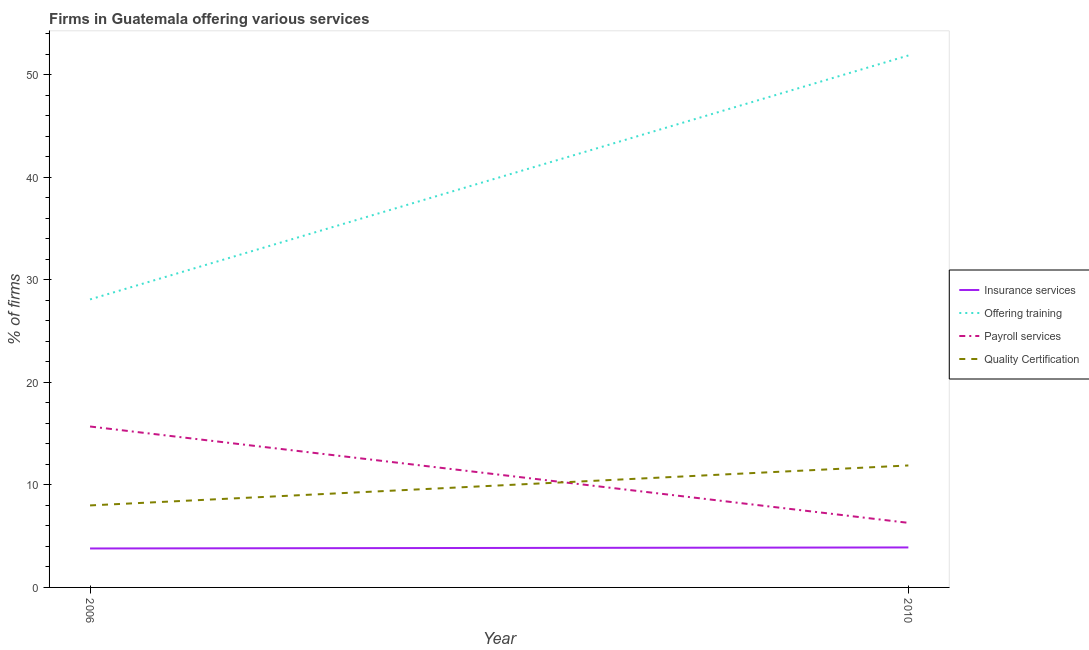What is the percentage of firms offering payroll services in 2006?
Your answer should be compact. 15.7. Across all years, what is the maximum percentage of firms offering payroll services?
Make the answer very short. 15.7. Across all years, what is the minimum percentage of firms offering quality certification?
Offer a very short reply. 8. In which year was the percentage of firms offering insurance services maximum?
Your answer should be very brief. 2010. What is the difference between the percentage of firms offering quality certification in 2006 and that in 2010?
Offer a very short reply. -3.9. What is the difference between the percentage of firms offering payroll services in 2006 and the percentage of firms offering insurance services in 2010?
Offer a very short reply. 11.8. What is the average percentage of firms offering insurance services per year?
Provide a succinct answer. 3.85. What is the ratio of the percentage of firms offering quality certification in 2006 to that in 2010?
Make the answer very short. 0.67. In how many years, is the percentage of firms offering payroll services greater than the average percentage of firms offering payroll services taken over all years?
Your answer should be very brief. 1. What is the difference between two consecutive major ticks on the Y-axis?
Give a very brief answer. 10. Are the values on the major ticks of Y-axis written in scientific E-notation?
Give a very brief answer. No. Does the graph contain any zero values?
Make the answer very short. No. Does the graph contain grids?
Keep it short and to the point. No. Where does the legend appear in the graph?
Your response must be concise. Center right. What is the title of the graph?
Keep it short and to the point. Firms in Guatemala offering various services . Does "Permission" appear as one of the legend labels in the graph?
Make the answer very short. No. What is the label or title of the Y-axis?
Your response must be concise. % of firms. What is the % of firms of Insurance services in 2006?
Keep it short and to the point. 3.8. What is the % of firms in Offering training in 2006?
Your answer should be very brief. 28.1. What is the % of firms in Payroll services in 2006?
Provide a short and direct response. 15.7. What is the % of firms of Offering training in 2010?
Offer a terse response. 51.9. Across all years, what is the maximum % of firms of Offering training?
Make the answer very short. 51.9. Across all years, what is the maximum % of firms of Payroll services?
Offer a very short reply. 15.7. Across all years, what is the maximum % of firms of Quality Certification?
Offer a very short reply. 11.9. Across all years, what is the minimum % of firms of Offering training?
Ensure brevity in your answer.  28.1. Across all years, what is the minimum % of firms in Quality Certification?
Ensure brevity in your answer.  8. What is the total % of firms of Insurance services in the graph?
Make the answer very short. 7.7. What is the total % of firms of Offering training in the graph?
Make the answer very short. 80. What is the total % of firms in Payroll services in the graph?
Keep it short and to the point. 22. What is the difference between the % of firms of Insurance services in 2006 and that in 2010?
Provide a succinct answer. -0.1. What is the difference between the % of firms in Offering training in 2006 and that in 2010?
Give a very brief answer. -23.8. What is the difference between the % of firms of Payroll services in 2006 and that in 2010?
Ensure brevity in your answer.  9.4. What is the difference between the % of firms in Quality Certification in 2006 and that in 2010?
Your answer should be very brief. -3.9. What is the difference between the % of firms in Insurance services in 2006 and the % of firms in Offering training in 2010?
Keep it short and to the point. -48.1. What is the difference between the % of firms of Insurance services in 2006 and the % of firms of Quality Certification in 2010?
Keep it short and to the point. -8.1. What is the difference between the % of firms in Offering training in 2006 and the % of firms in Payroll services in 2010?
Provide a short and direct response. 21.8. What is the difference between the % of firms of Offering training in 2006 and the % of firms of Quality Certification in 2010?
Provide a short and direct response. 16.2. What is the average % of firms of Insurance services per year?
Give a very brief answer. 3.85. What is the average % of firms in Payroll services per year?
Your answer should be compact. 11. What is the average % of firms in Quality Certification per year?
Ensure brevity in your answer.  9.95. In the year 2006, what is the difference between the % of firms in Insurance services and % of firms in Offering training?
Make the answer very short. -24.3. In the year 2006, what is the difference between the % of firms in Offering training and % of firms in Payroll services?
Provide a short and direct response. 12.4. In the year 2006, what is the difference between the % of firms in Offering training and % of firms in Quality Certification?
Offer a terse response. 20.1. In the year 2006, what is the difference between the % of firms in Payroll services and % of firms in Quality Certification?
Provide a succinct answer. 7.7. In the year 2010, what is the difference between the % of firms of Insurance services and % of firms of Offering training?
Offer a terse response. -48. In the year 2010, what is the difference between the % of firms of Insurance services and % of firms of Payroll services?
Ensure brevity in your answer.  -2.4. In the year 2010, what is the difference between the % of firms in Offering training and % of firms in Payroll services?
Provide a short and direct response. 45.6. In the year 2010, what is the difference between the % of firms in Offering training and % of firms in Quality Certification?
Your answer should be very brief. 40. In the year 2010, what is the difference between the % of firms in Payroll services and % of firms in Quality Certification?
Make the answer very short. -5.6. What is the ratio of the % of firms in Insurance services in 2006 to that in 2010?
Ensure brevity in your answer.  0.97. What is the ratio of the % of firms in Offering training in 2006 to that in 2010?
Your answer should be very brief. 0.54. What is the ratio of the % of firms of Payroll services in 2006 to that in 2010?
Your answer should be compact. 2.49. What is the ratio of the % of firms in Quality Certification in 2006 to that in 2010?
Offer a terse response. 0.67. What is the difference between the highest and the second highest % of firms of Insurance services?
Offer a terse response. 0.1. What is the difference between the highest and the second highest % of firms in Offering training?
Make the answer very short. 23.8. What is the difference between the highest and the lowest % of firms of Insurance services?
Your answer should be compact. 0.1. What is the difference between the highest and the lowest % of firms of Offering training?
Ensure brevity in your answer.  23.8. 